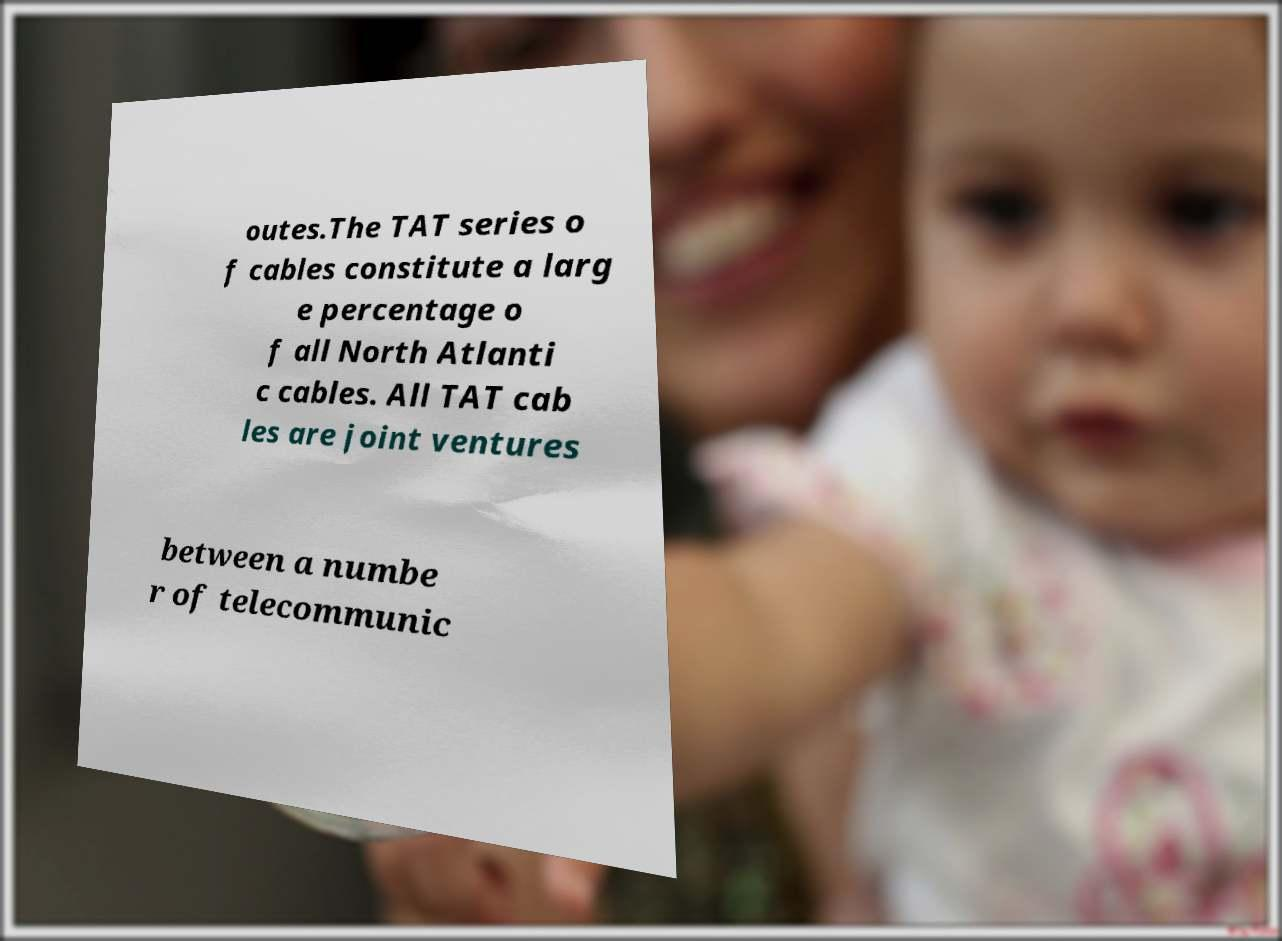Please read and relay the text visible in this image. What does it say? outes.The TAT series o f cables constitute a larg e percentage o f all North Atlanti c cables. All TAT cab les are joint ventures between a numbe r of telecommunic 